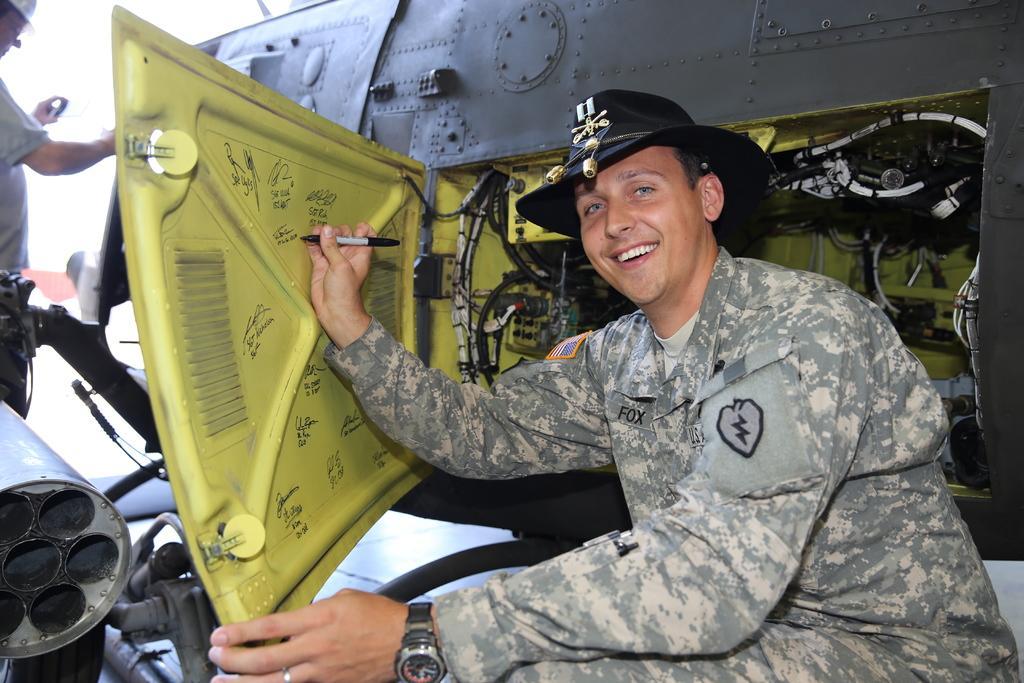Describe this image in one or two sentences. In the image we can see there is a person sitting near the machine and he is holding pen in his hand. He is wearing a hat and there is another person standing. 